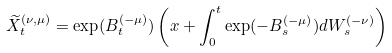<formula> <loc_0><loc_0><loc_500><loc_500>\widetilde { X } _ { t } ^ { ( \nu , \mu ) } = \exp ( B _ { t } ^ { ( - \mu ) } ) \left ( x + \int _ { 0 } ^ { t } \exp ( - B _ { s } ^ { ( - \mu ) } ) d W _ { s } ^ { ( - \nu ) } \right )</formula> 